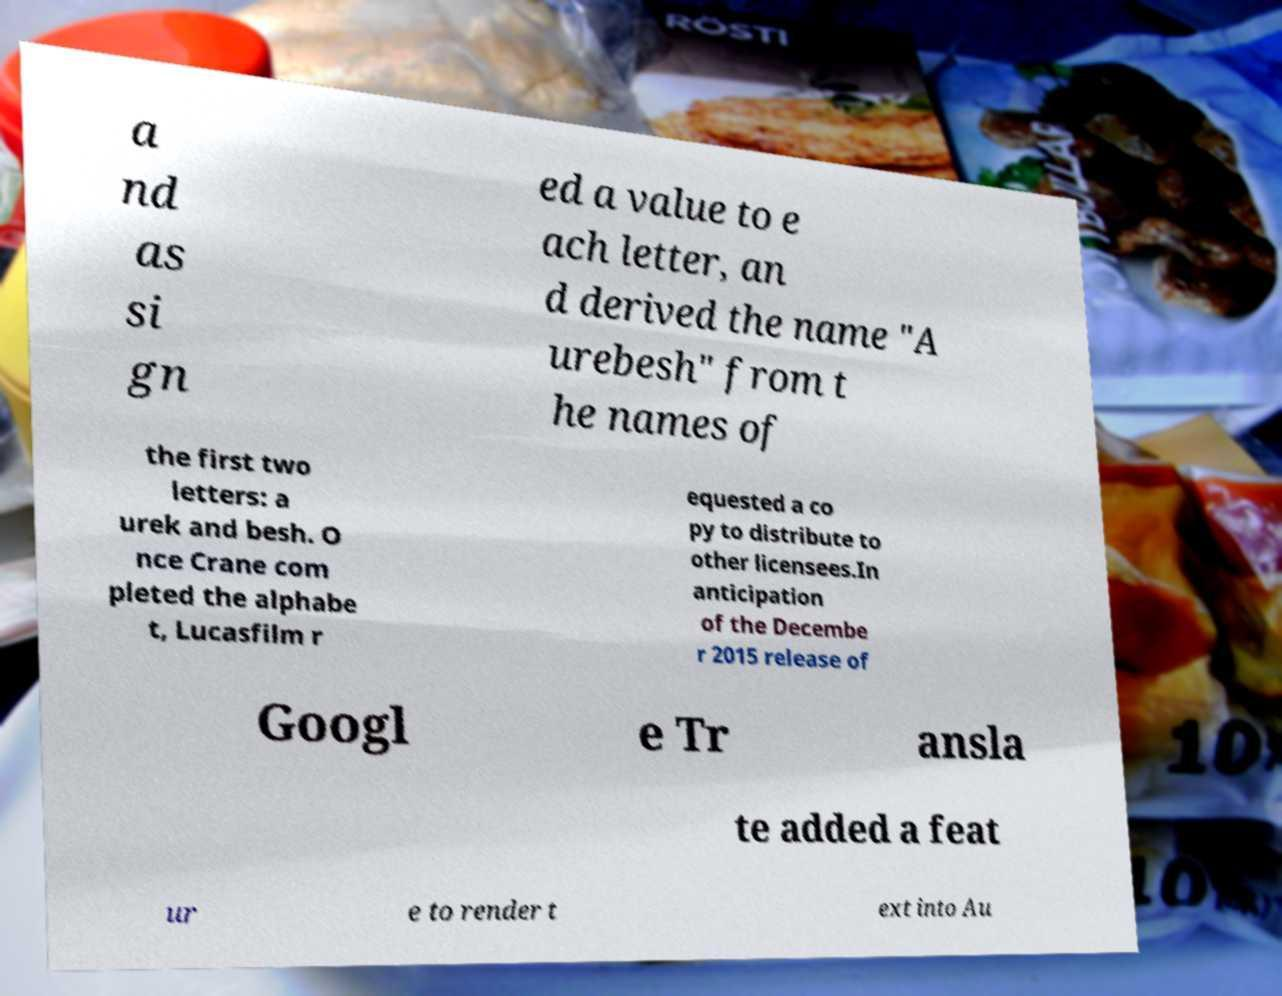Please read and relay the text visible in this image. What does it say? a nd as si gn ed a value to e ach letter, an d derived the name "A urebesh" from t he names of the first two letters: a urek and besh. O nce Crane com pleted the alphabe t, Lucasfilm r equested a co py to distribute to other licensees.In anticipation of the Decembe r 2015 release of Googl e Tr ansla te added a feat ur e to render t ext into Au 